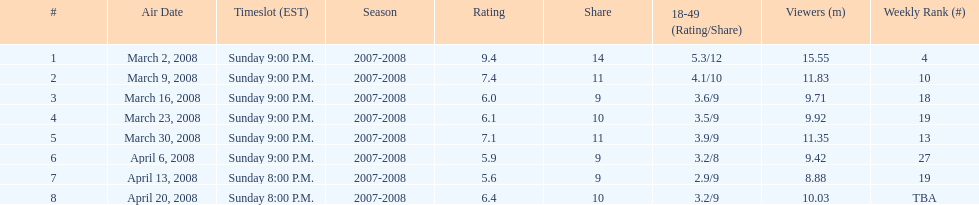Which show had the highest rating? 1. 